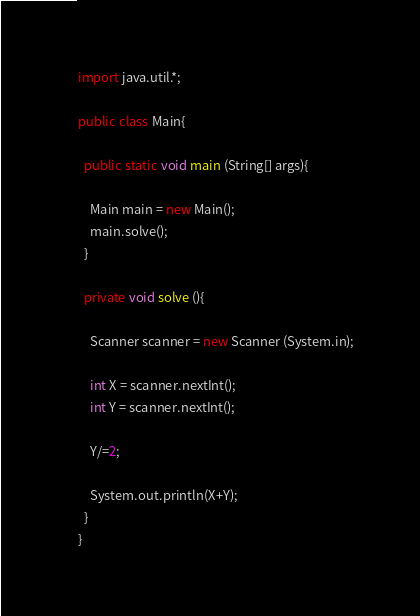Convert code to text. <code><loc_0><loc_0><loc_500><loc_500><_Java_>import java.util.*;

public class Main{
  
  public static void main (String[] args){
    
    Main main = new Main();
    main.solve();
  }
  
  private void solve (){
    
    Scanner scanner = new Scanner (System.in);
    
    int X = scanner.nextInt();
    int Y = scanner.nextInt();
    
    Y/=2;
    
    System.out.println(X+Y);
  }
}</code> 